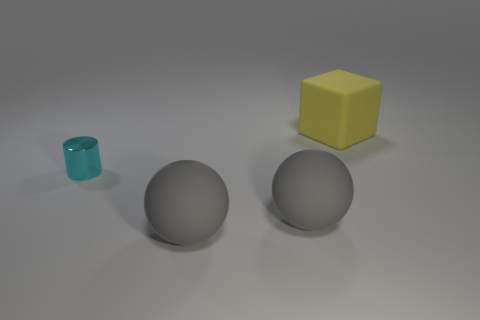What number of large rubber things are behind the yellow object?
Provide a short and direct response. 0. Are there any other matte cubes that have the same color as the large matte cube?
Give a very brief answer. No. Is there anything else that is the same color as the small object?
Ensure brevity in your answer.  No. There is a rubber object behind the cyan cylinder; what color is it?
Your response must be concise. Yellow. Are there more yellow things that are to the right of the yellow matte thing than shiny cylinders?
Provide a short and direct response. No. Is the shape of the big matte thing behind the cylinder the same as  the cyan shiny object?
Give a very brief answer. No. Is there anything else that has the same material as the cylinder?
Provide a short and direct response. No. How many objects are large matte spheres or objects in front of the metallic cylinder?
Give a very brief answer. 2. Is the number of large matte blocks that are on the right side of the big yellow object greater than the number of yellow objects in front of the cyan metallic object?
Your answer should be compact. No. Is the shape of the cyan metal object the same as the object that is behind the shiny object?
Provide a short and direct response. No. 